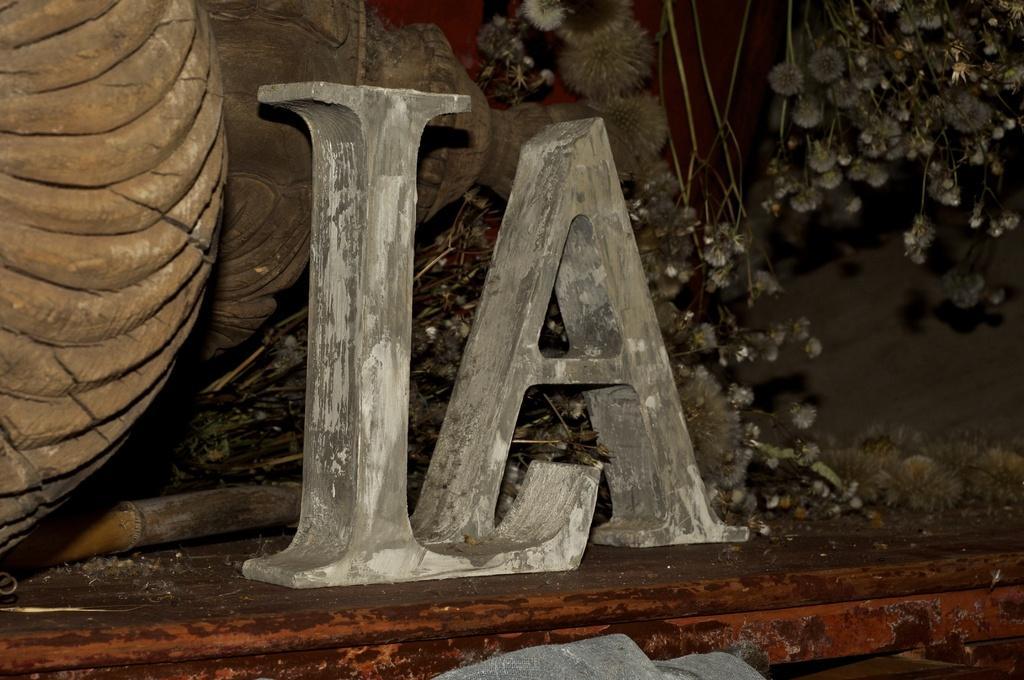Describe this image in one or two sentences. This image is clicked in the dark. In the center of the image I can see two letters L and A and some other objects on the left side of the image. On the right side of the image I can see a plant. 